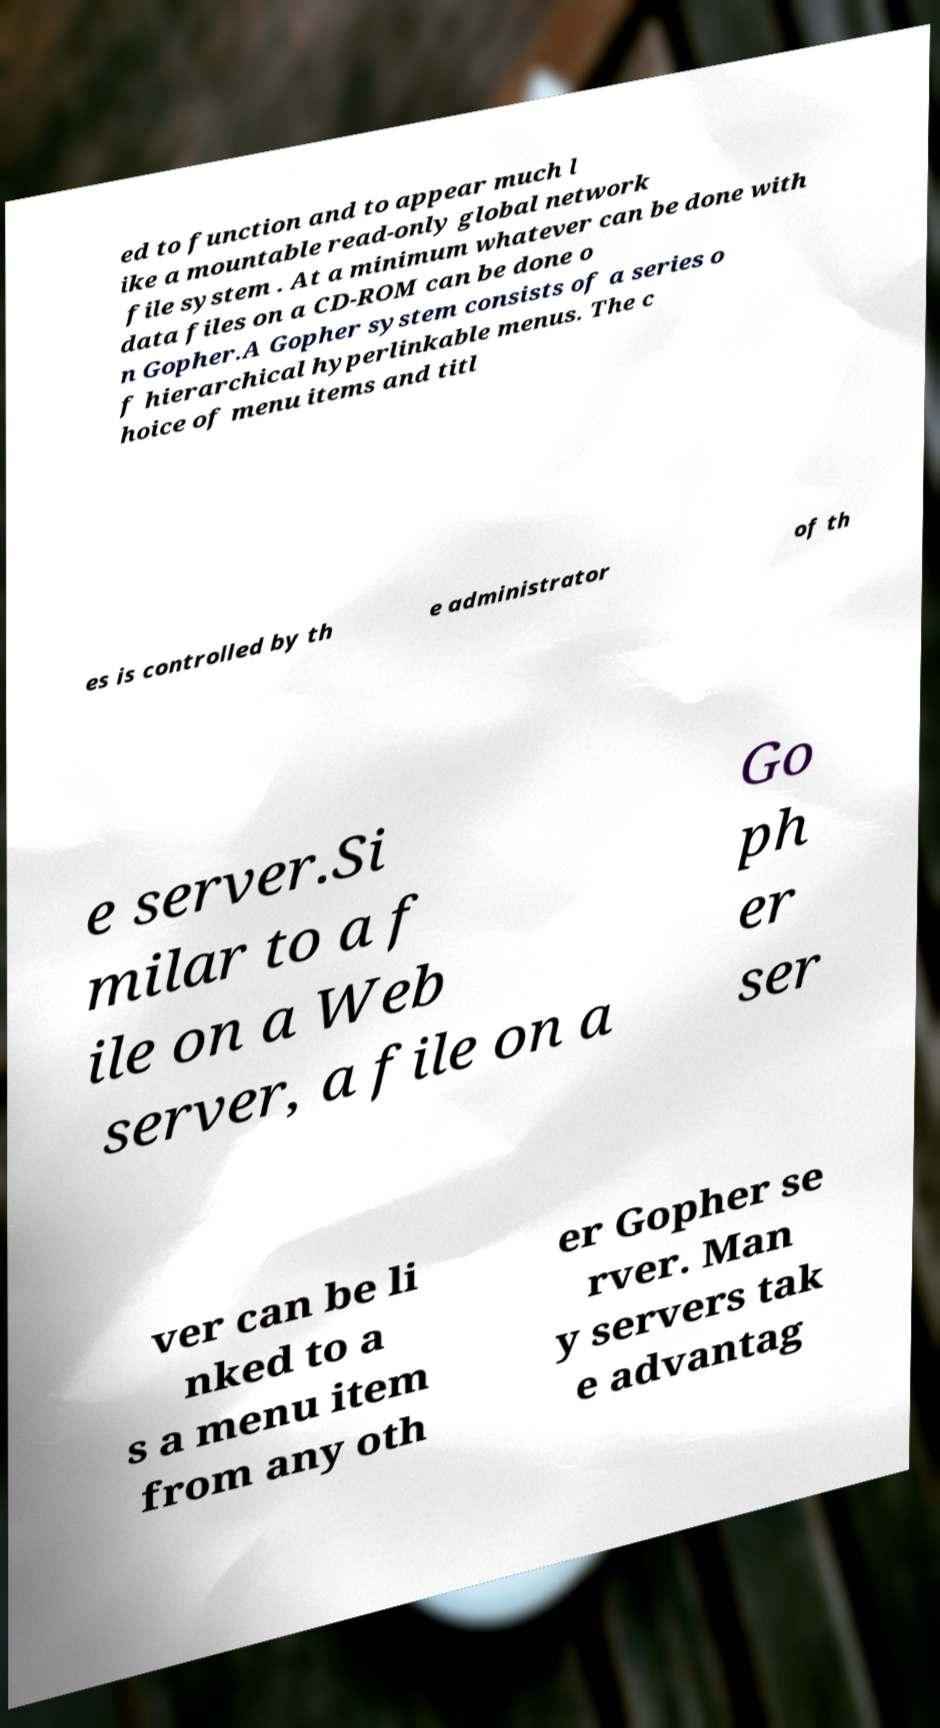Could you extract and type out the text from this image? ed to function and to appear much l ike a mountable read-only global network file system . At a minimum whatever can be done with data files on a CD-ROM can be done o n Gopher.A Gopher system consists of a series o f hierarchical hyperlinkable menus. The c hoice of menu items and titl es is controlled by th e administrator of th e server.Si milar to a f ile on a Web server, a file on a Go ph er ser ver can be li nked to a s a menu item from any oth er Gopher se rver. Man y servers tak e advantag 